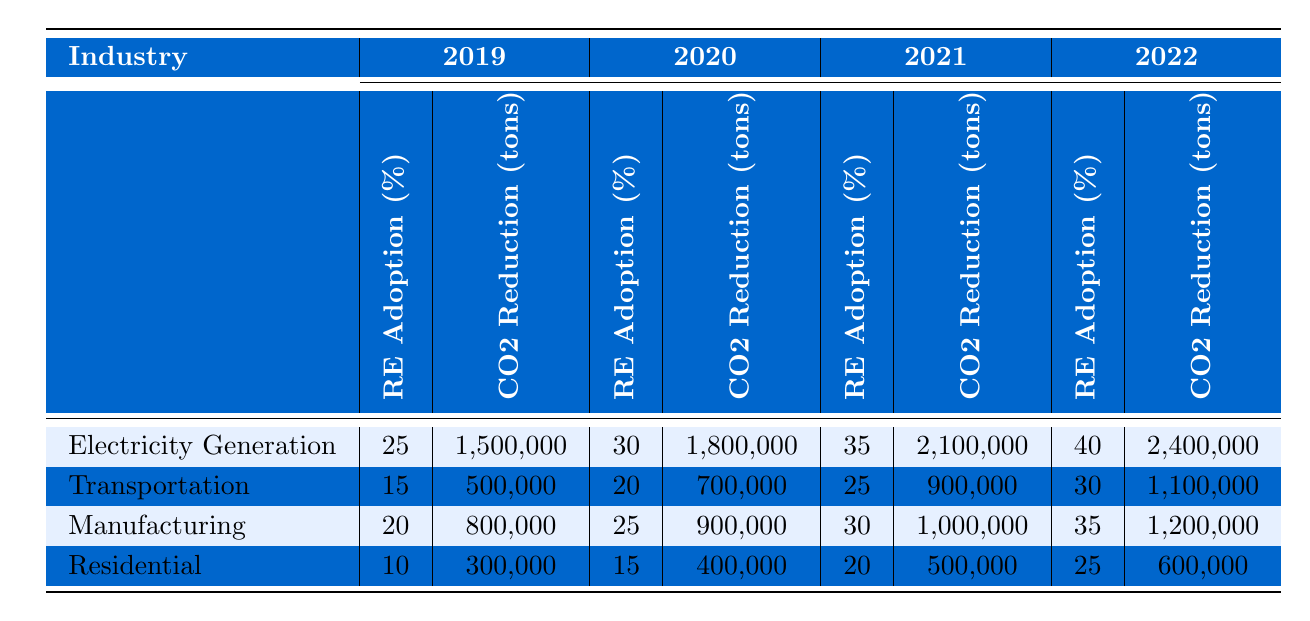What was the CO2 emissions reduction in the Electricity Generation industry in 2021? Referring to the table, the CO2 emissions reduction for the Electricity Generation industry in 2021 is listed as 2,100,000 tons.
Answer: 2,100,000 tons Which industry had the highest percentage of renewable energy adoption in 2022? Looking at the table, in 2022 the Electricity Generation industry had the highest renewable energy adoption at 40%.
Answer: Electricity Generation What is the total CO2 emissions reduction for the Transportation industry from 2019 to 2022? By summing the CO2 emissions reductions for the Transportation industry over the four years from the table: 500,000 + 700,000 + 900,000 + 1,100,000 = 3,200,000 tons.
Answer: 3,200,000 tons Did the Renewable Energy adoption percentage in the Manufacturing industry increase every year from 2019 to 2022? Checking the table, the Renewable Energy adoption percentages for Manufacturing are 20%, 25%, 30%, and 35% from 2019 to 2022, which indicates a consistent increase.
Answer: Yes What was the average CO2 emissions reduction across all industries in 2020? First, identify the reductions for each industry in 2020: Electricity Generation (1,800,000), Transportation (700,000), Manufacturing (900,000), Residential (400,000). The total is 1,800,000 + 700,000 + 900,000 + 400,000 = 3,800,000 tons. Dividing by 4 industries gives an average of 3,800,000 / 4 = 950,000 tons.
Answer: 950,000 tons How much did the Residential industry's CO2 emissions reduction increase from 2019 to 2022? The reduction in 2019 was 300,000 tons and in 2022 it was 600,000 tons. The increase is 600,000 - 300,000 = 300,000 tons.
Answer: 300,000 tons Which industry reduced the least amount of CO2 emissions in 2021? In 2021, the CO2 emissions reductions for each industry were: Electricity Generation (2,100,000), Transportation (900,000), Manufacturing (1,000,000), and Residential (500,000). The least is 500,000 tons (Residential).
Answer: Residential If we sum the Renewable Energy adoption percentages for all industries in 2019, what is the total? The Renewable Energy adoption percentages in 2019 are: Electricity Generation (25%), Transportation (15%), Manufacturing (20%), and Residential (10%). Summing these gives 25 + 15 + 20 + 10 = 70%.
Answer: 70% 